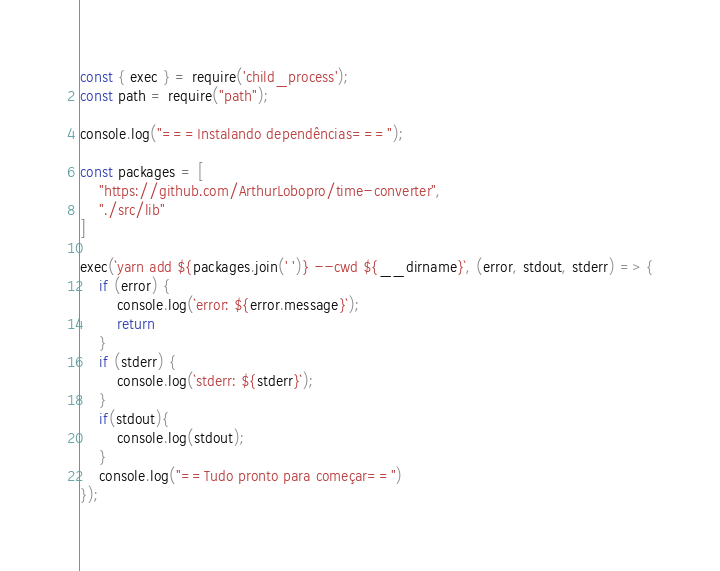<code> <loc_0><loc_0><loc_500><loc_500><_JavaScript_>const { exec } = require('child_process');
const path = require("path");

console.log("===Instalando dependências===");

const packages = [
    "https://github.com/ArthurLobopro/time-converter",
    "./src/lib"
]

exec(`yarn add ${packages.join(' ')} --cwd ${__dirname}`, (error, stdout, stderr) => {
    if (error) {
        console.log(`error: ${error.message}`);
        return
    }
    if (stderr) {
        console.log(`stderr: ${stderr}`);
    }
    if(stdout){
        console.log(stdout);
    }
    console.log("==Tudo pronto para começar==")
});</code> 